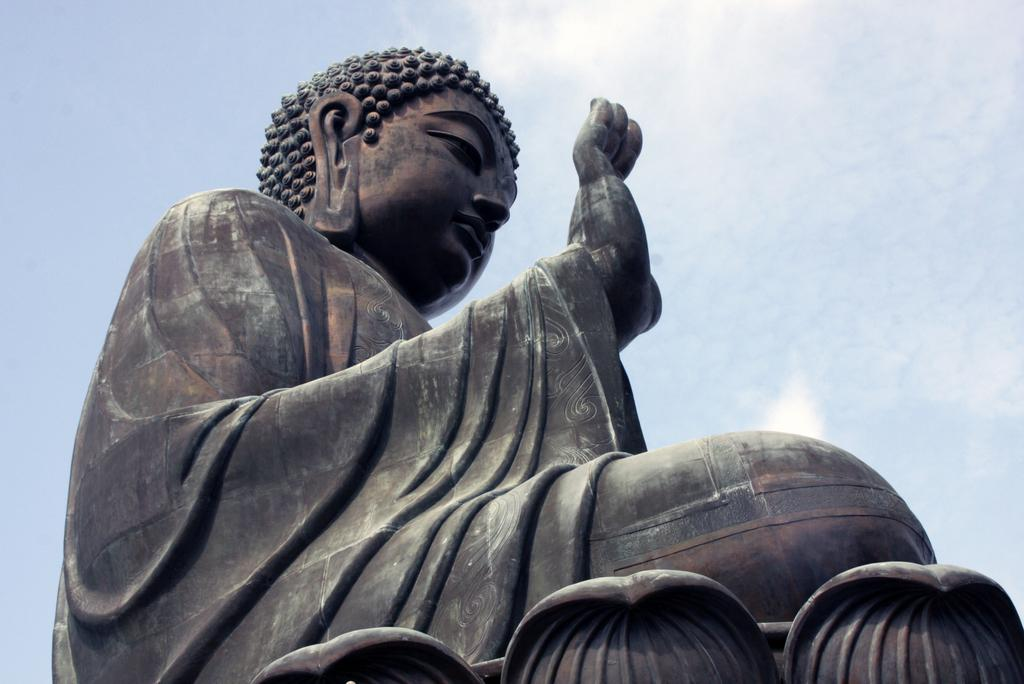What is the main subject of the image? There is a statue of Buddha in the image. Can you describe the color of the statue? The statue is in black and brown color. What can be seen in the background of the image? The sky is visible in the background of the image. What type of health advice can be found in the image? There is no health advice present in the image; it features a statue of Buddha with a black and brown color, and the sky is visible in the background. 